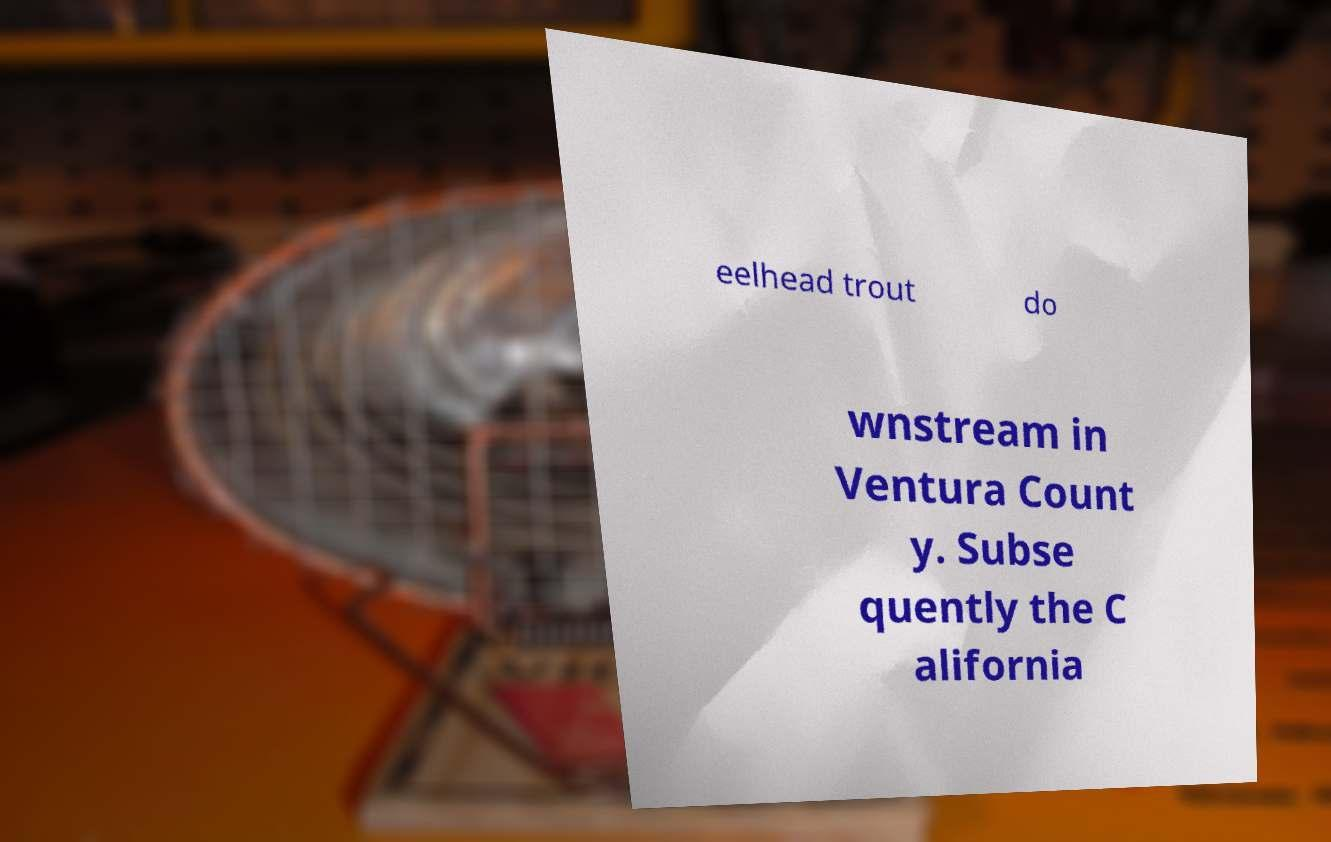For documentation purposes, I need the text within this image transcribed. Could you provide that? eelhead trout do wnstream in Ventura Count y. Subse quently the C alifornia 